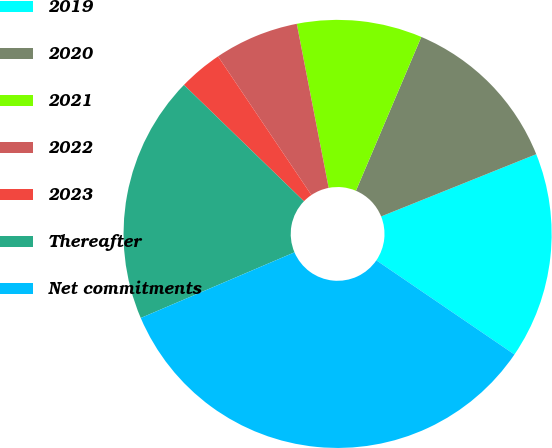Convert chart to OTSL. <chart><loc_0><loc_0><loc_500><loc_500><pie_chart><fcel>2019<fcel>2020<fcel>2021<fcel>2022<fcel>2023<fcel>Thereafter<fcel>Net commitments<nl><fcel>15.6%<fcel>12.53%<fcel>9.45%<fcel>6.38%<fcel>3.31%<fcel>18.68%<fcel>34.05%<nl></chart> 